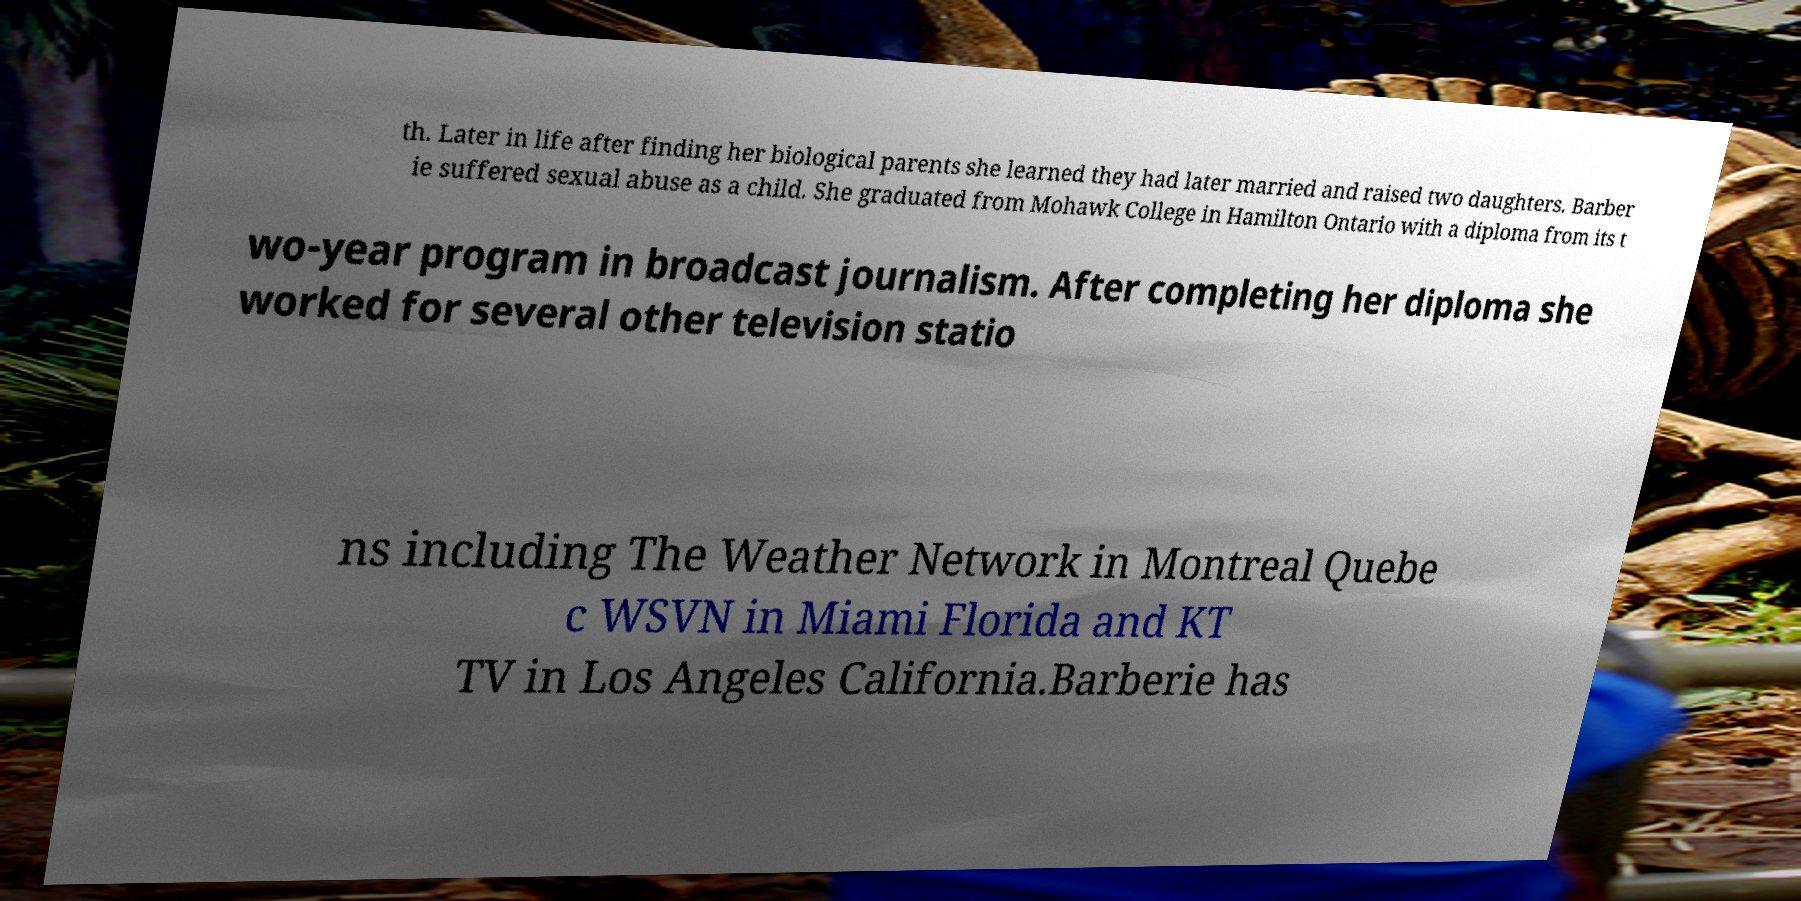Could you assist in decoding the text presented in this image and type it out clearly? th. Later in life after finding her biological parents she learned they had later married and raised two daughters. Barber ie suffered sexual abuse as a child. She graduated from Mohawk College in Hamilton Ontario with a diploma from its t wo-year program in broadcast journalism. After completing her diploma she worked for several other television statio ns including The Weather Network in Montreal Quebe c WSVN in Miami Florida and KT TV in Los Angeles California.Barberie has 